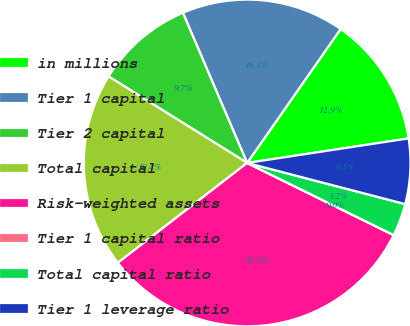Convert chart to OTSL. <chart><loc_0><loc_0><loc_500><loc_500><pie_chart><fcel>in millions<fcel>Tier 1 capital<fcel>Tier 2 capital<fcel>Total capital<fcel>Risk-weighted assets<fcel>Tier 1 capital ratio<fcel>Total capital ratio<fcel>Tier 1 leverage ratio<nl><fcel>12.9%<fcel>16.13%<fcel>9.68%<fcel>19.35%<fcel>32.25%<fcel>0.0%<fcel>3.23%<fcel>6.45%<nl></chart> 